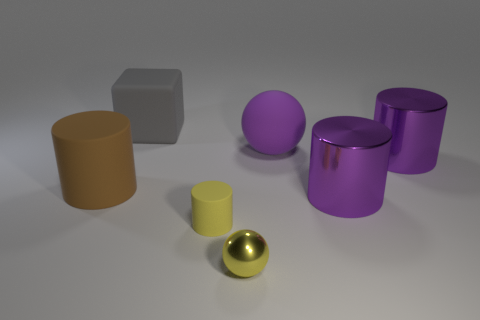What is the shape of the brown object that is the same size as the gray block?
Offer a terse response. Cylinder. Is there a metallic sphere of the same color as the small rubber thing?
Provide a succinct answer. Yes. Is the shape of the big brown object the same as the small metallic object?
Provide a succinct answer. No. How many big things are cylinders or matte cylinders?
Your response must be concise. 3. What color is the big cylinder that is the same material as the big ball?
Keep it short and to the point. Brown. How many gray objects are made of the same material as the large brown object?
Your response must be concise. 1. Is the size of the yellow object behind the tiny shiny thing the same as the matte thing that is behind the purple rubber sphere?
Make the answer very short. No. What is the material of the ball behind the tiny thing behind the tiny yellow sphere?
Make the answer very short. Rubber. Is the number of purple rubber objects that are behind the yellow sphere less than the number of objects that are on the right side of the large gray rubber cube?
Your answer should be very brief. Yes. There is another small thing that is the same color as the tiny matte object; what is its material?
Ensure brevity in your answer.  Metal. 